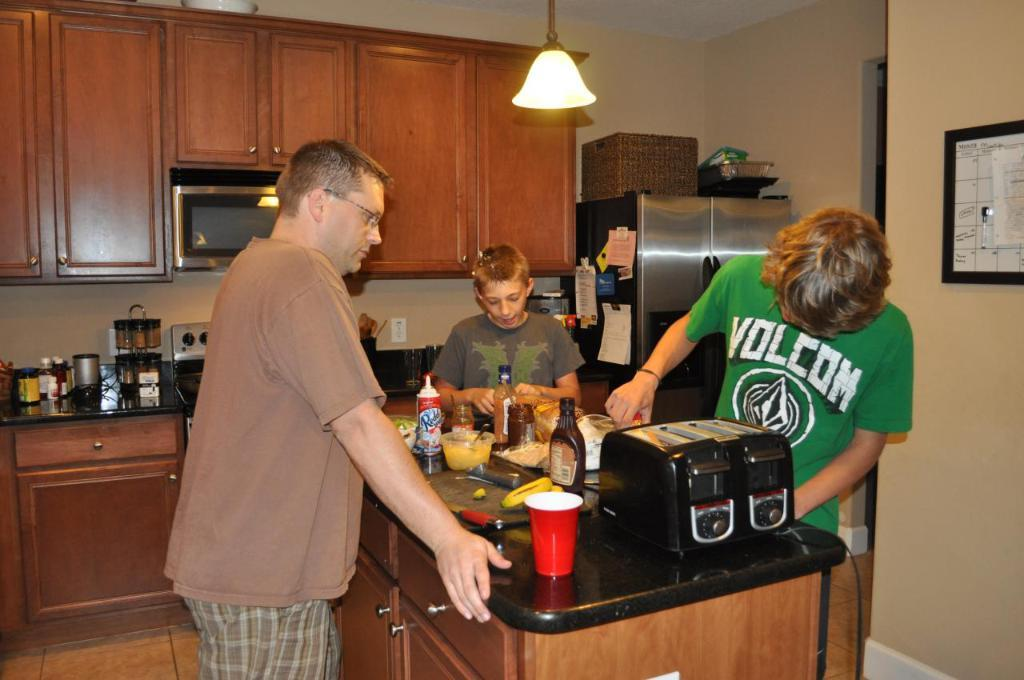Provide a one-sentence caption for the provided image. Three people, including one wearing a green Volcom shirt, stand at a counter. 